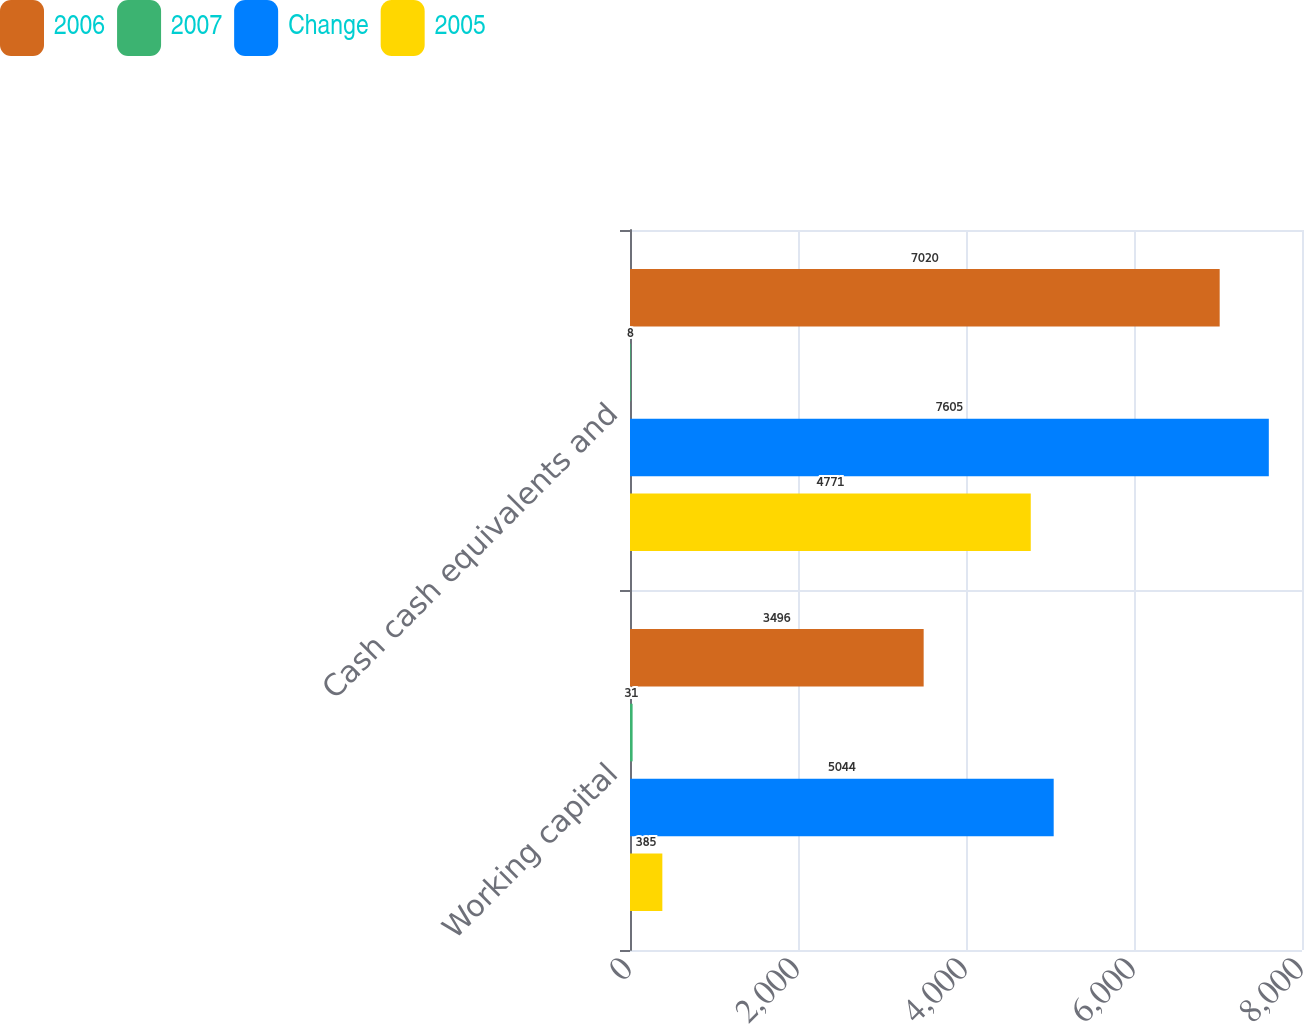Convert chart. <chart><loc_0><loc_0><loc_500><loc_500><stacked_bar_chart><ecel><fcel>Working capital<fcel>Cash cash equivalents and<nl><fcel>2006<fcel>3496<fcel>7020<nl><fcel>2007<fcel>31<fcel>8<nl><fcel>Change<fcel>5044<fcel>7605<nl><fcel>2005<fcel>385<fcel>4771<nl></chart> 